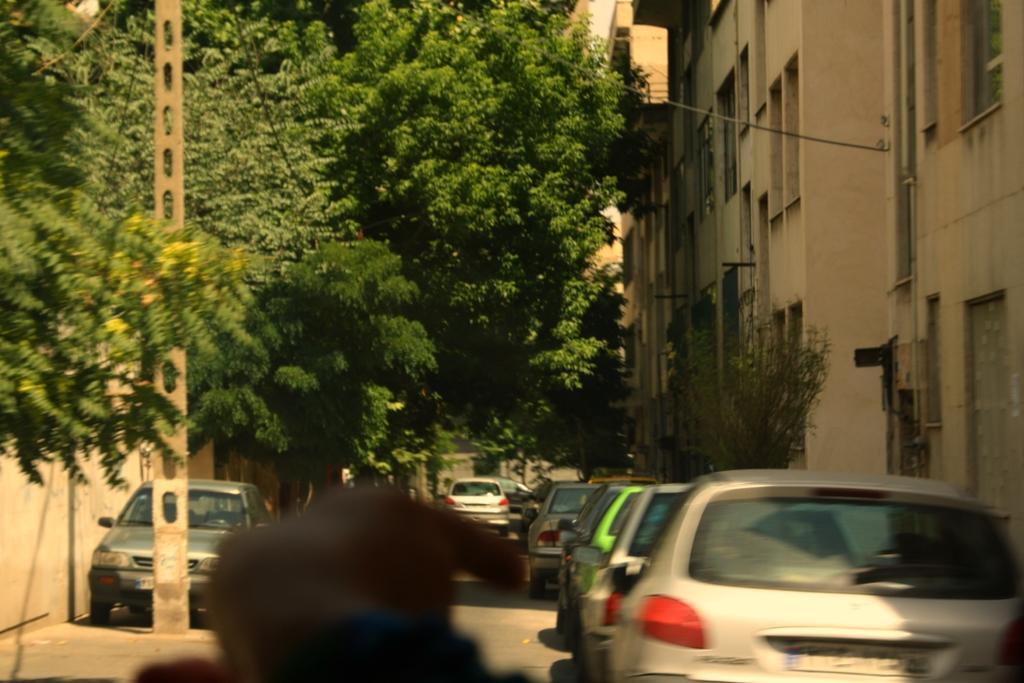Can you describe this image briefly? In this image we can see a few vehicles, there are some buildings, trees, wires, windows and a pole. 